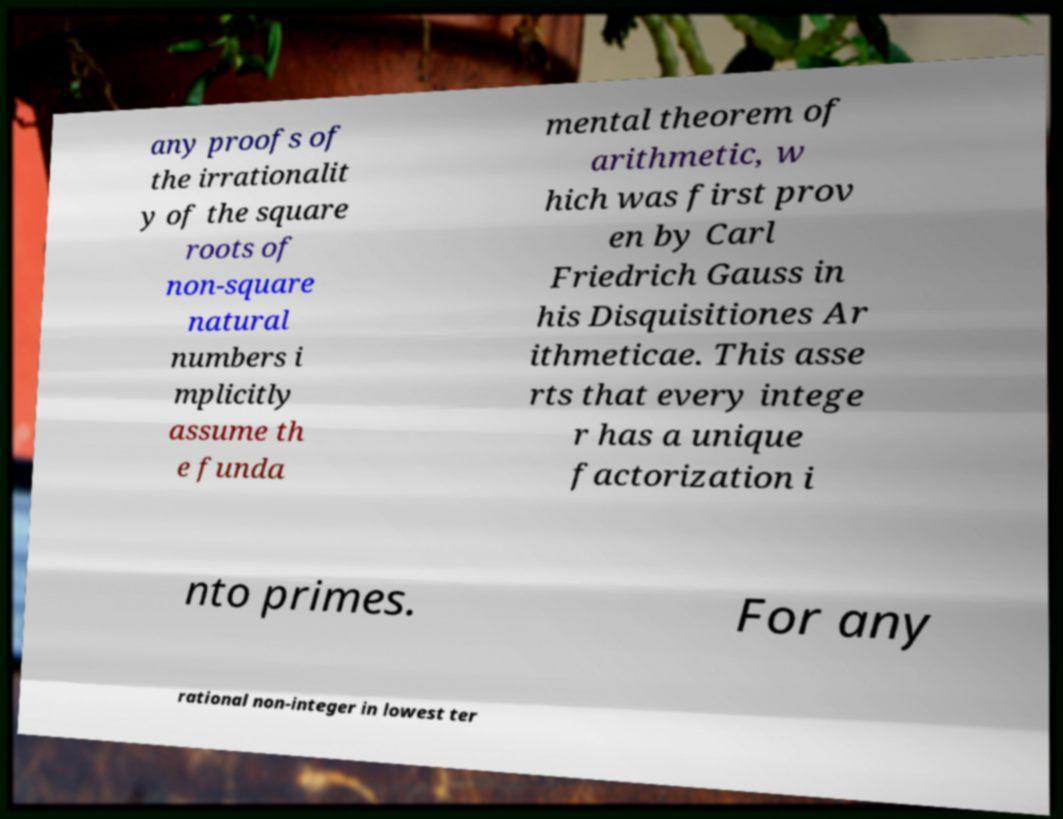Can you read and provide the text displayed in the image?This photo seems to have some interesting text. Can you extract and type it out for me? any proofs of the irrationalit y of the square roots of non-square natural numbers i mplicitly assume th e funda mental theorem of arithmetic, w hich was first prov en by Carl Friedrich Gauss in his Disquisitiones Ar ithmeticae. This asse rts that every intege r has a unique factorization i nto primes. For any rational non-integer in lowest ter 